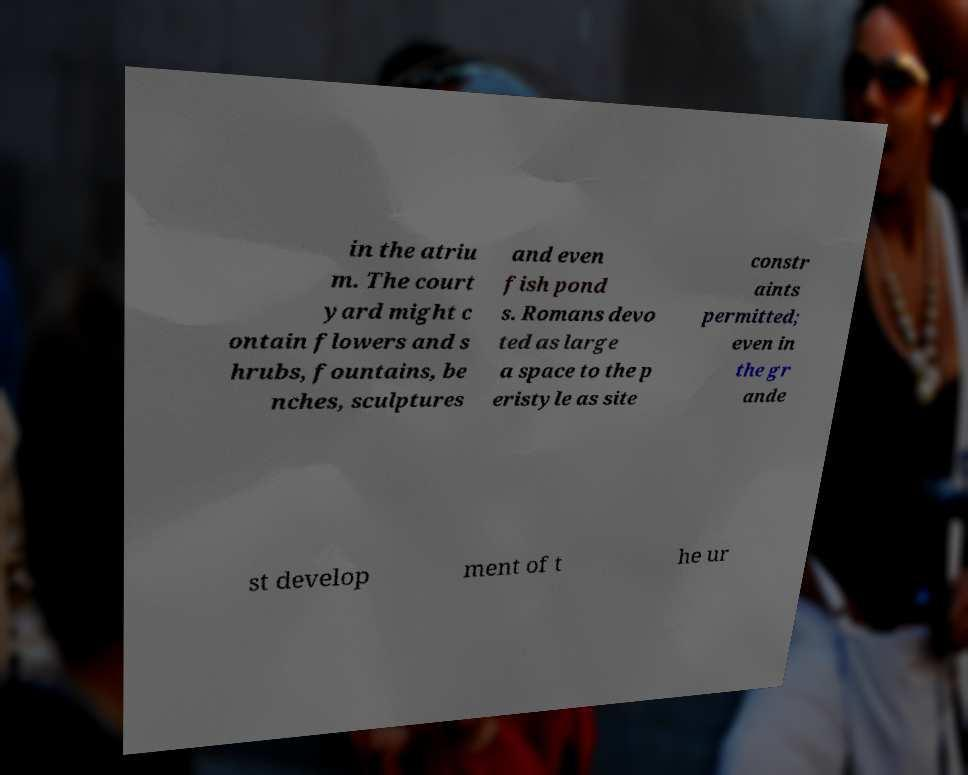What messages or text are displayed in this image? I need them in a readable, typed format. in the atriu m. The court yard might c ontain flowers and s hrubs, fountains, be nches, sculptures and even fish pond s. Romans devo ted as large a space to the p eristyle as site constr aints permitted; even in the gr ande st develop ment of t he ur 